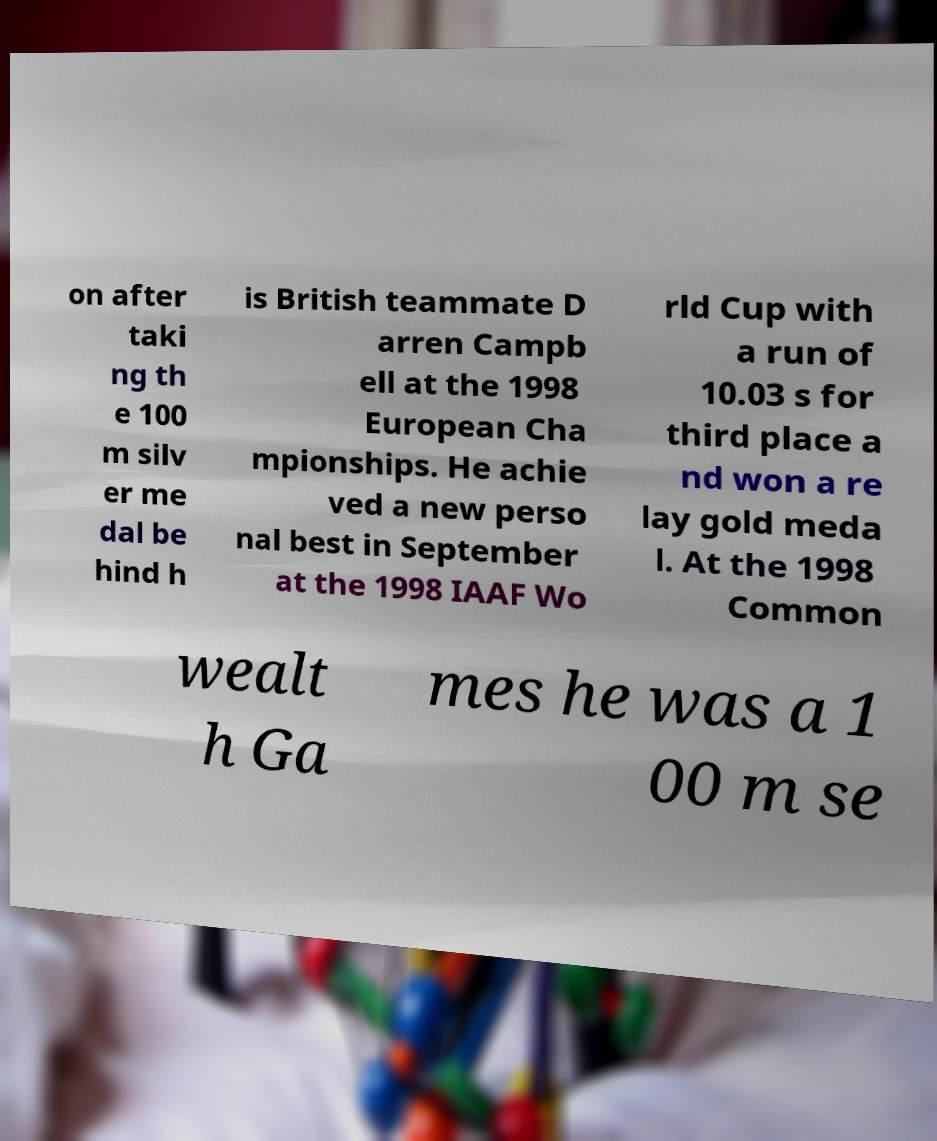What messages or text are displayed in this image? I need them in a readable, typed format. on after taki ng th e 100 m silv er me dal be hind h is British teammate D arren Campb ell at the 1998 European Cha mpionships. He achie ved a new perso nal best in September at the 1998 IAAF Wo rld Cup with a run of 10.03 s for third place a nd won a re lay gold meda l. At the 1998 Common wealt h Ga mes he was a 1 00 m se 